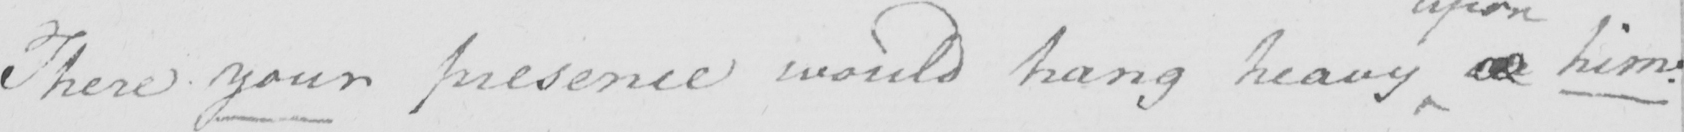What text is written in this handwritten line? There your presence would hang heavy on him . 